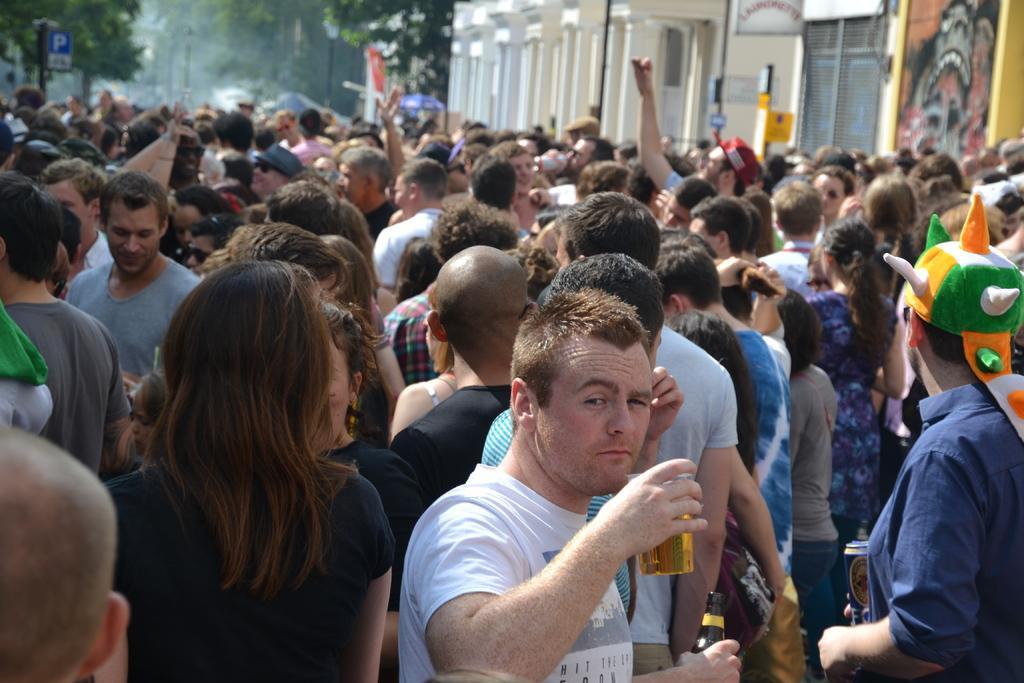Can you describe this image briefly? In this image, there is a crowd wearing colorful clothes and standing in front of this building. There is a tree in the top left. This person is holding a glass. This person is wearing a cap on his head. 